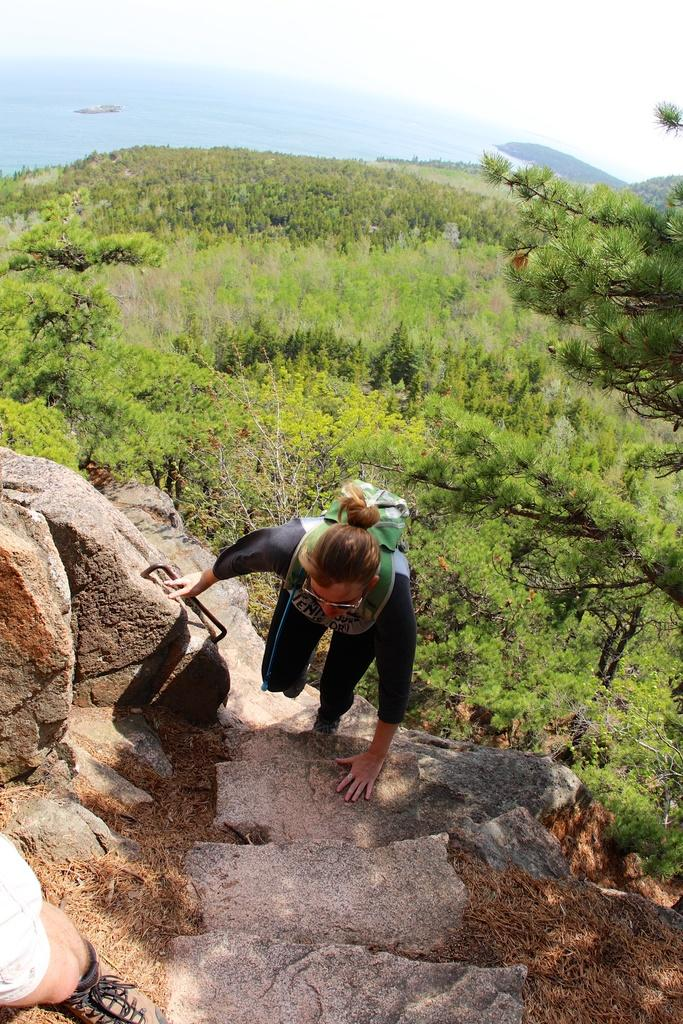What is the person in the image doing? The person is climbing a rock in the image. What type of natural environment is visible behind the person? There is grass and trees on the surface behind the person. What can be seen in the distance in the image? There is water visible in the background of the image. How many wrenches are being used by the person climbing the rock in the image? There are no wrenches visible in the image; the person is climbing a rock without any tools. 